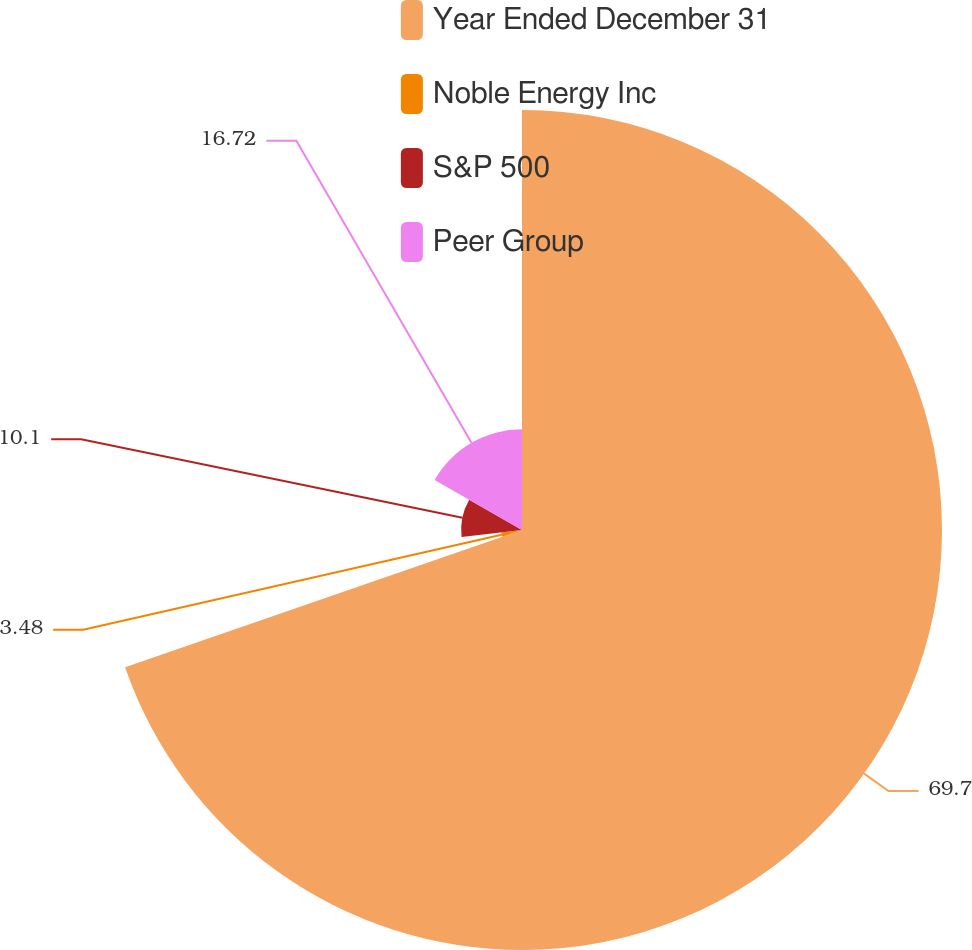Convert chart. <chart><loc_0><loc_0><loc_500><loc_500><pie_chart><fcel>Year Ended December 31<fcel>Noble Energy Inc<fcel>S&P 500<fcel>Peer Group<nl><fcel>69.7%<fcel>3.48%<fcel>10.1%<fcel>16.72%<nl></chart> 